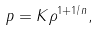<formula> <loc_0><loc_0><loc_500><loc_500>p = K \rho ^ { 1 + 1 / n } ,</formula> 